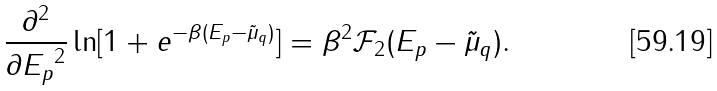Convert formula to latex. <formula><loc_0><loc_0><loc_500><loc_500>\frac { \partial ^ { 2 } } { \partial { E _ { p } } ^ { 2 } } \ln [ 1 + e ^ { - \beta ( E _ { p } - \tilde { \mu } _ { q } ) } ] = \beta ^ { 2 } \mathcal { F } _ { 2 } ( E _ { p } - \tilde { \mu } _ { q } ) .</formula> 